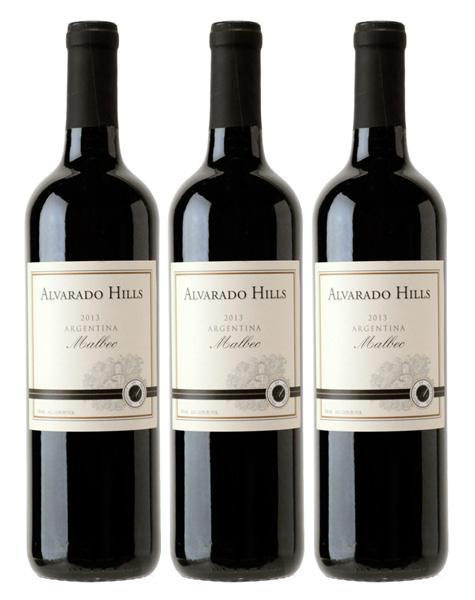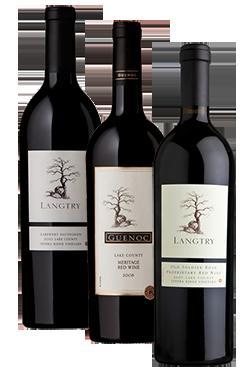The first image is the image on the left, the second image is the image on the right. Given the left and right images, does the statement "Exactly three bottles are displayed in a level row with none of them touching or overlapping." hold true? Answer yes or no. Yes. The first image is the image on the left, the second image is the image on the right. Considering the images on both sides, is "The left image contains exactly four bottles of wine." valid? Answer yes or no. No. 